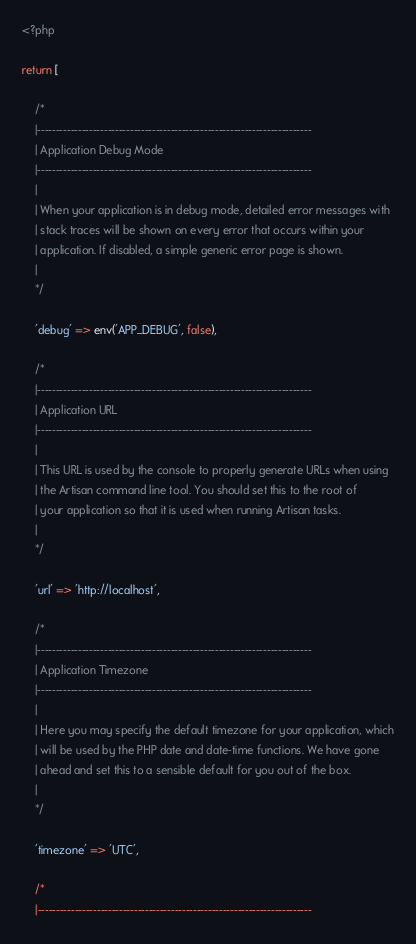Convert code to text. <code><loc_0><loc_0><loc_500><loc_500><_PHP_><?php

return [

    /*
    |--------------------------------------------------------------------------
    | Application Debug Mode
    |--------------------------------------------------------------------------
    |
    | When your application is in debug mode, detailed error messages with
    | stack traces will be shown on every error that occurs within your
    | application. If disabled, a simple generic error page is shown.
    |
    */

    'debug' => env('APP_DEBUG', false),

    /*
    |--------------------------------------------------------------------------
    | Application URL
    |--------------------------------------------------------------------------
    |
    | This URL is used by the console to properly generate URLs when using
    | the Artisan command line tool. You should set this to the root of
    | your application so that it is used when running Artisan tasks.
    |
    */

    'url' => 'http://localhost',

    /*
    |--------------------------------------------------------------------------
    | Application Timezone
    |--------------------------------------------------------------------------
    |
    | Here you may specify the default timezone for your application, which
    | will be used by the PHP date and date-time functions. We have gone
    | ahead and set this to a sensible default for you out of the box.
    |
    */

    'timezone' => 'UTC',

    /*
    |--------------------------------------------------------------------------</code> 